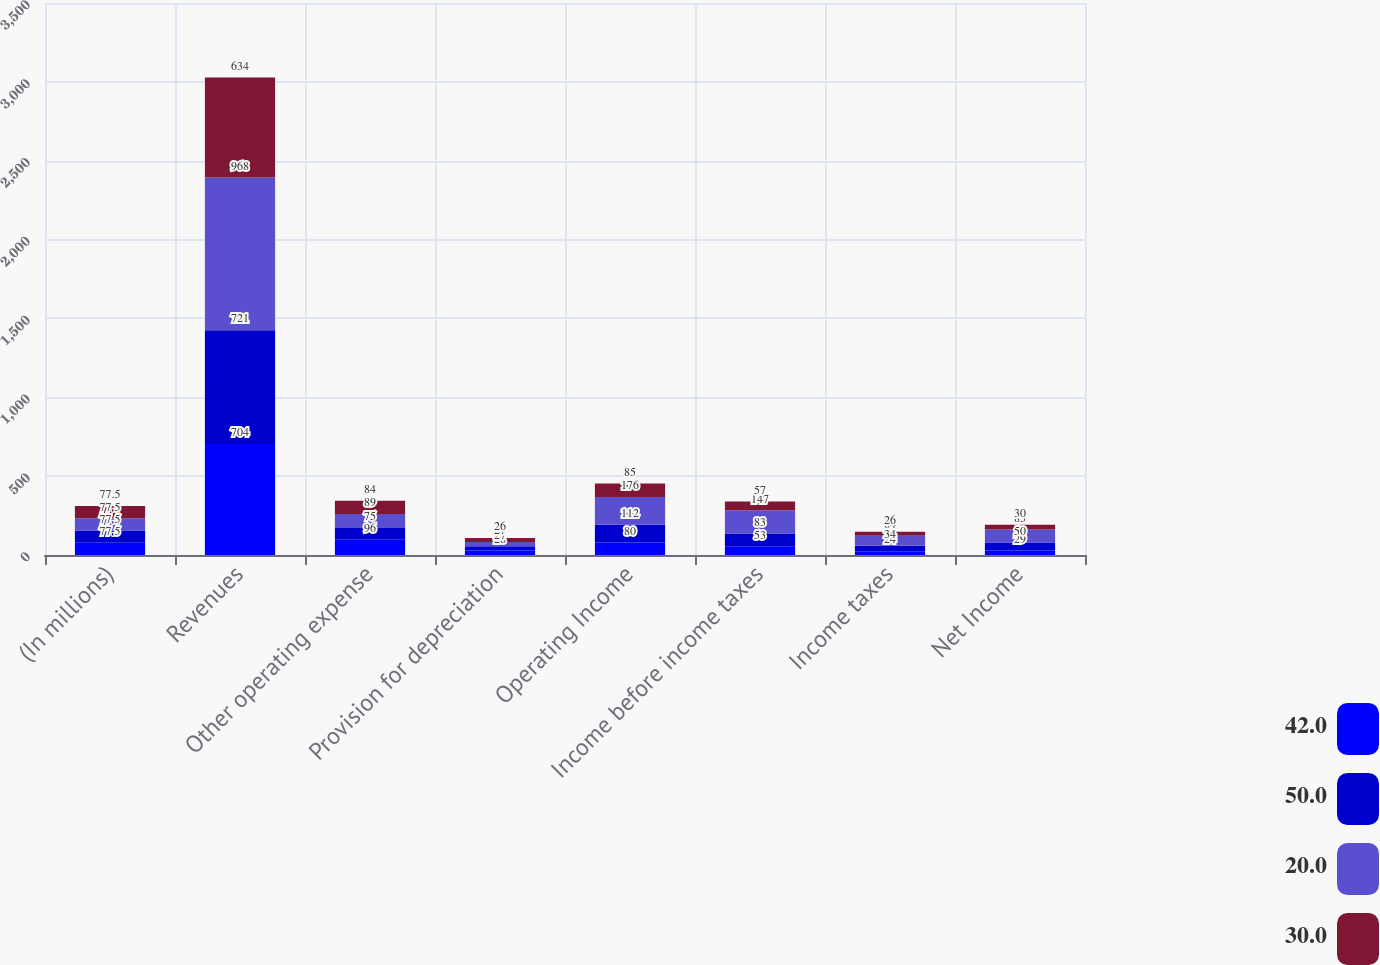Convert chart to OTSL. <chart><loc_0><loc_0><loc_500><loc_500><stacked_bar_chart><ecel><fcel>(In millions)<fcel>Revenues<fcel>Other operating expense<fcel>Provision for depreciation<fcel>Operating Income<fcel>Income before income taxes<fcel>Income taxes<fcel>Net Income<nl><fcel>42<fcel>77.5<fcel>704<fcel>96<fcel>28<fcel>80<fcel>53<fcel>24<fcel>29<nl><fcel>50<fcel>77.5<fcel>721<fcel>75<fcel>27<fcel>112<fcel>83<fcel>34<fcel>50<nl><fcel>20<fcel>77.5<fcel>968<fcel>89<fcel>27<fcel>176<fcel>147<fcel>64<fcel>83<nl><fcel>30<fcel>77.5<fcel>634<fcel>84<fcel>26<fcel>85<fcel>57<fcel>26<fcel>30<nl></chart> 